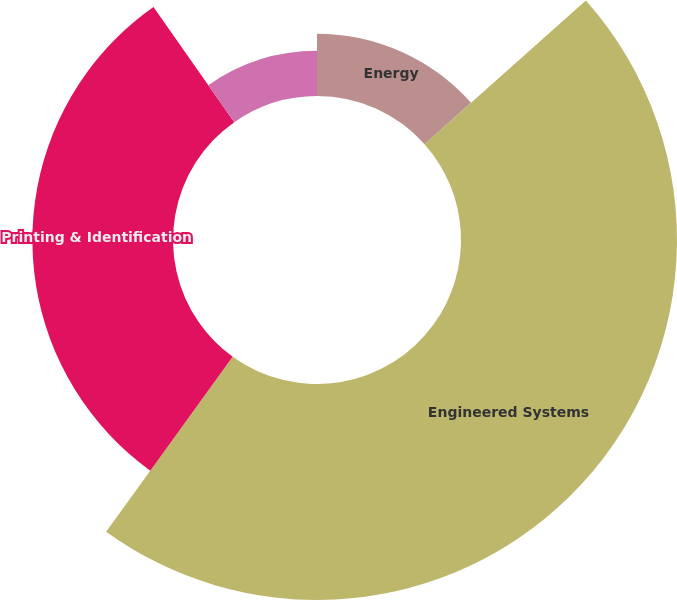Convert chart to OTSL. <chart><loc_0><loc_0><loc_500><loc_500><pie_chart><fcel>Energy<fcel>Engineered Systems<fcel>Printing & Identification<fcel>Communication Technologies<nl><fcel>13.42%<fcel>46.54%<fcel>30.3%<fcel>9.74%<nl></chart> 